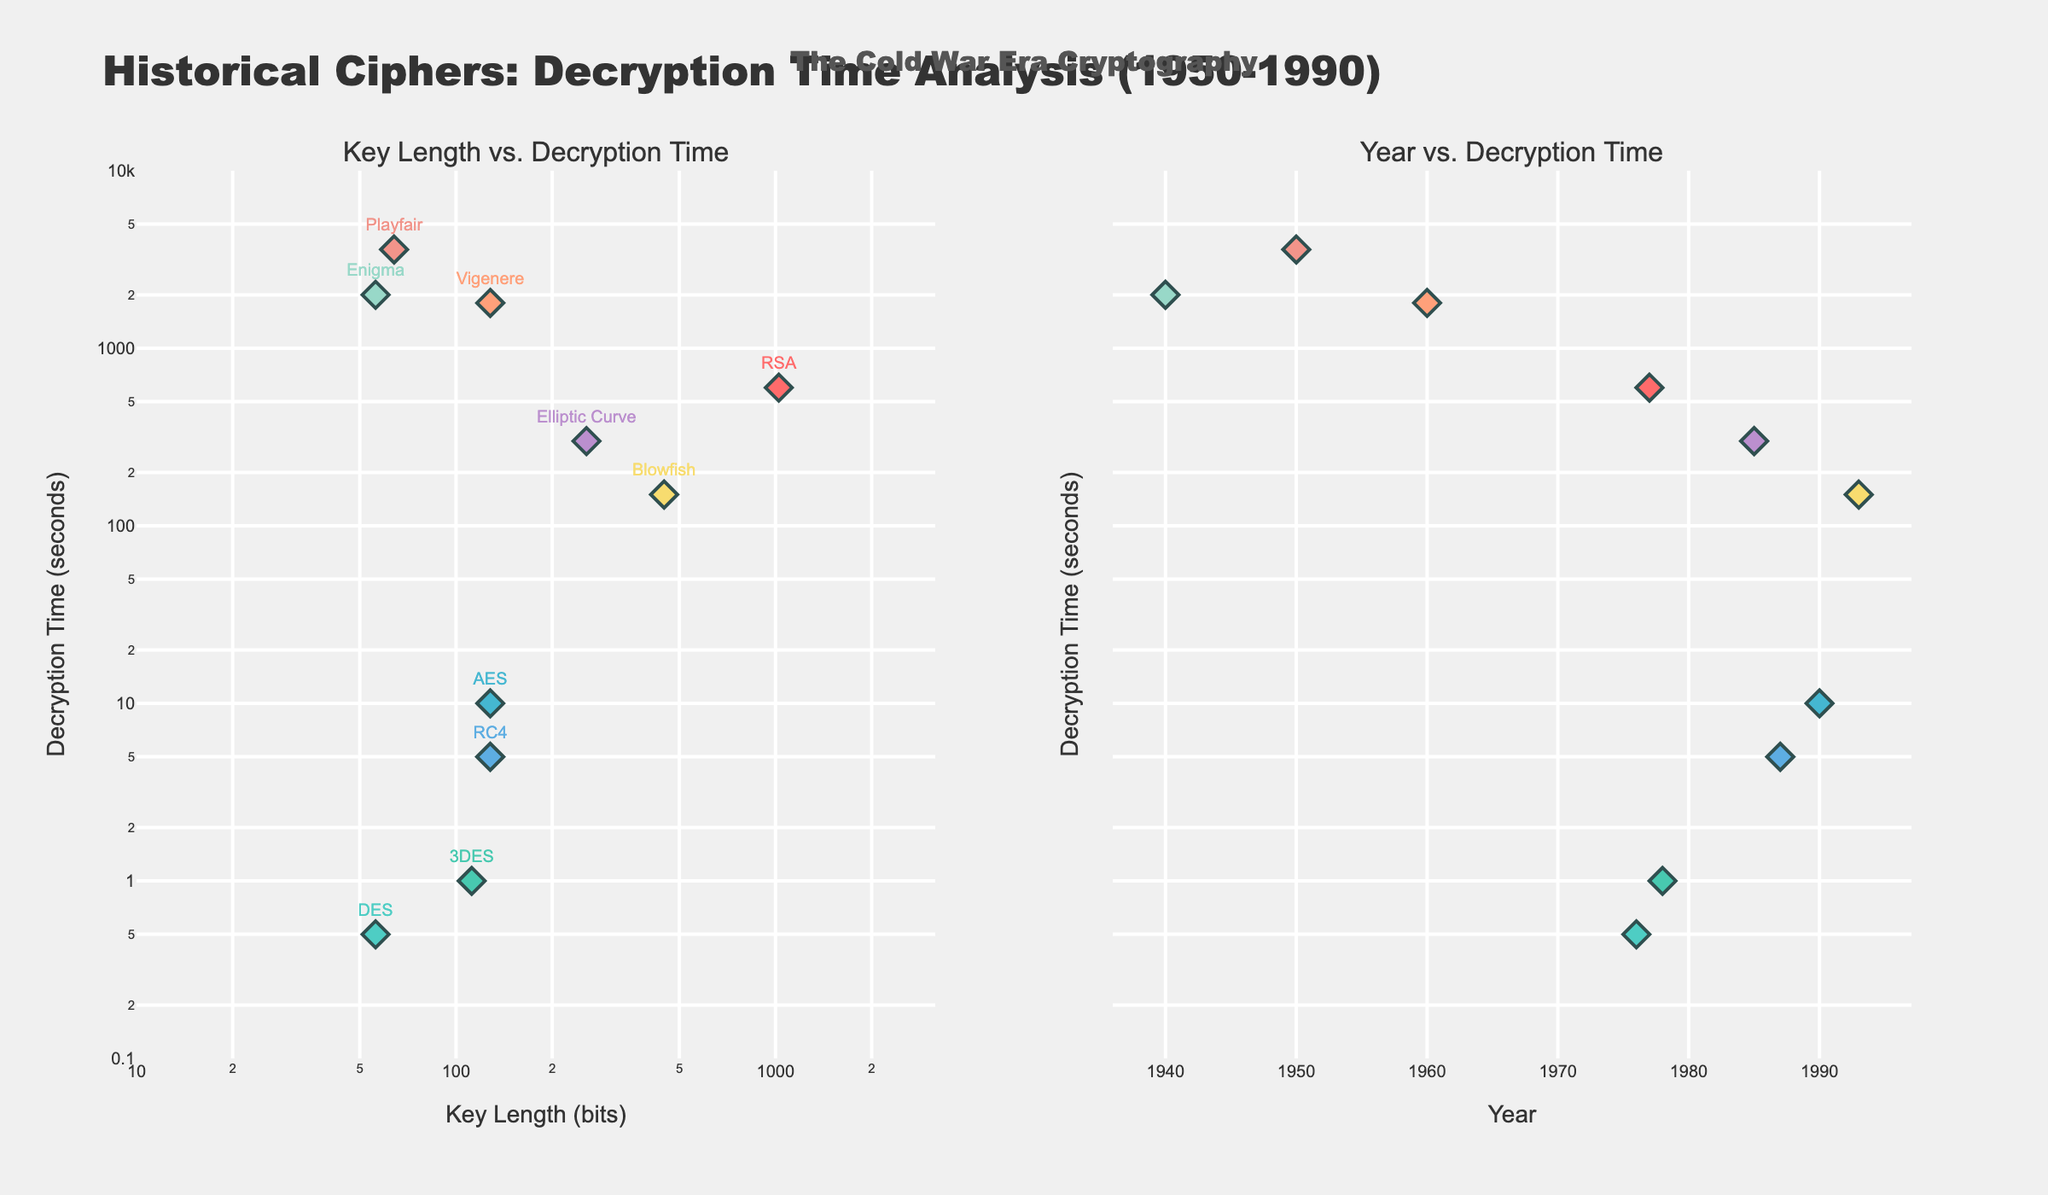What's the title of the figure? The title is located at the top of the figure. It is labeled "Historical Ciphers: Decryption Time Analysis (1950-1990)".
Answer: Historical Ciphers: Decryption Time Analysis (1950-1990) What's the x-axis label on the left subplot? The x-axis label on the left subplot is indicated at the bottom of the x-axis. It is "Key Length (bits)".
Answer: Key Length (bits) How many years are represented in the figure? The years are plotted on the x-axis of the right subplot. By counting the unique year labels, we have: 1950, 1960, 1976, 1977, 1978, 1985, 1987, 1990, and 1993. This gives us a total of 9 distinct years.
Answer: 9 Which cipher has the longest decryption time? By looking at the y-axis, the maximum decryption time is at the top. The Vigenere cipher has the highest point with 3600 seconds.
Answer: Playfair What was the decryption time for the AES cipher in 1990? Find the data point for AES on the plot and refer to its corresponding y-axis value. You will see that it aligns with 10 seconds.
Answer: 10 seconds Which cipher has the shortest decryption time and what is it? By looking at the other end of the y-axis, the minimum decryption time is at the bottom. The DES cipher has the lowest point with 0.5 seconds.
Answer: DES, 0.5 seconds How is the decryption time of Playfair in 1950 compared to Enigma in 1940? Both ciphers can be identified by their markers in the left subplot. Playfair has a decryption time of 3600 seconds, and Enigma has a decryption time of 2000 seconds. Comparing these values, Playfair takes longer.
Answer: Playfair takes longer What is the relationship between key length and decryption time in the left subplot? In the left subplot, observe the data points. It can be noted that ciphers with shorter key lengths tend to have lower decryption times, while ciphers with longer key lengths span a broad range of decryption times.
Answer: Longer key lengths do not always mean longer decryption times When did the Elliptic Curve cipher appear in the timeline? Locate the Elliptic Curve on the right subplot. It is positioned at the year 1985 along the x-axis.
Answer: 1985 